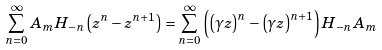<formula> <loc_0><loc_0><loc_500><loc_500>\sum _ { n = 0 } ^ { \infty } A _ { m } H _ { - n } \left ( z ^ { n } - z ^ { n + 1 } \right ) = \sum _ { n = 0 } ^ { \infty } \left ( \left ( \gamma z \right ) ^ { n } - \left ( \gamma z \right ) ^ { n + 1 } \right ) H _ { - n } A _ { m }</formula> 